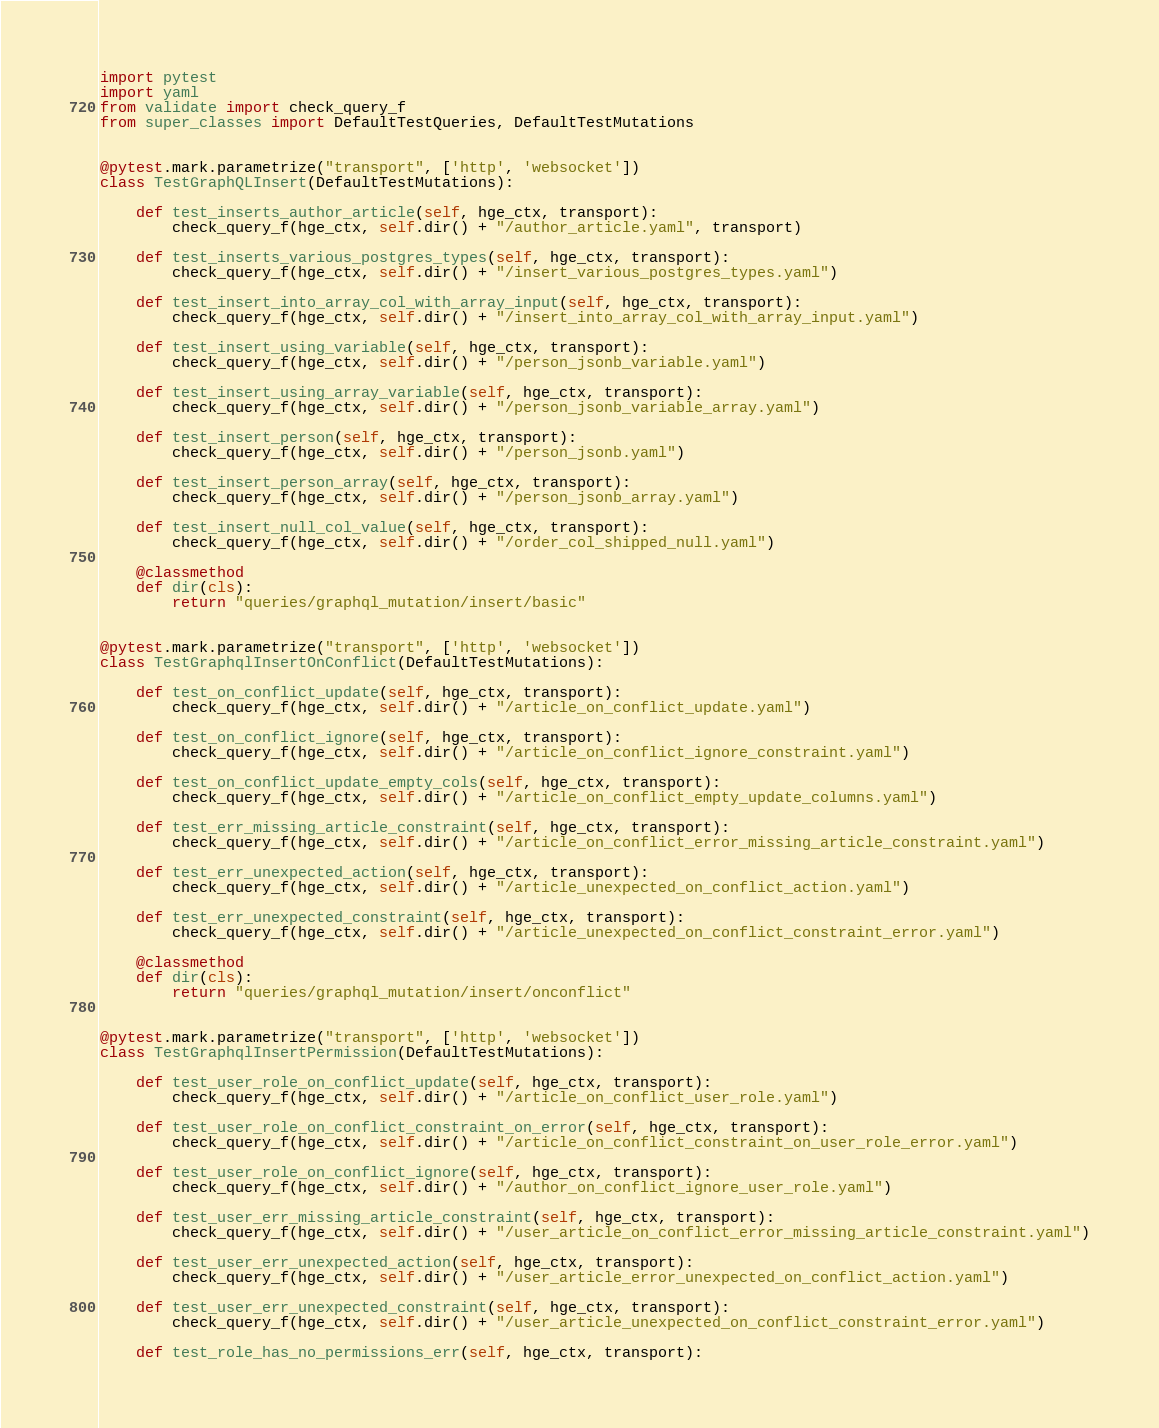<code> <loc_0><loc_0><loc_500><loc_500><_Python_>import pytest
import yaml
from validate import check_query_f
from super_classes import DefaultTestQueries, DefaultTestMutations


@pytest.mark.parametrize("transport", ['http', 'websocket'])
class TestGraphQLInsert(DefaultTestMutations):

    def test_inserts_author_article(self, hge_ctx, transport):
        check_query_f(hge_ctx, self.dir() + "/author_article.yaml", transport)

    def test_inserts_various_postgres_types(self, hge_ctx, transport):
        check_query_f(hge_ctx, self.dir() + "/insert_various_postgres_types.yaml")

    def test_insert_into_array_col_with_array_input(self, hge_ctx, transport):
        check_query_f(hge_ctx, self.dir() + "/insert_into_array_col_with_array_input.yaml")

    def test_insert_using_variable(self, hge_ctx, transport):
        check_query_f(hge_ctx, self.dir() + "/person_jsonb_variable.yaml")

    def test_insert_using_array_variable(self, hge_ctx, transport):
        check_query_f(hge_ctx, self.dir() + "/person_jsonb_variable_array.yaml")

    def test_insert_person(self, hge_ctx, transport):
        check_query_f(hge_ctx, self.dir() + "/person_jsonb.yaml")

    def test_insert_person_array(self, hge_ctx, transport):
        check_query_f(hge_ctx, self.dir() + "/person_jsonb_array.yaml")

    def test_insert_null_col_value(self, hge_ctx, transport):
        check_query_f(hge_ctx, self.dir() + "/order_col_shipped_null.yaml")

    @classmethod
    def dir(cls):
        return "queries/graphql_mutation/insert/basic"


@pytest.mark.parametrize("transport", ['http', 'websocket'])
class TestGraphqlInsertOnConflict(DefaultTestMutations):

    def test_on_conflict_update(self, hge_ctx, transport):
        check_query_f(hge_ctx, self.dir() + "/article_on_conflict_update.yaml")

    def test_on_conflict_ignore(self, hge_ctx, transport):
        check_query_f(hge_ctx, self.dir() + "/article_on_conflict_ignore_constraint.yaml")

    def test_on_conflict_update_empty_cols(self, hge_ctx, transport):
        check_query_f(hge_ctx, self.dir() + "/article_on_conflict_empty_update_columns.yaml")

    def test_err_missing_article_constraint(self, hge_ctx, transport):
        check_query_f(hge_ctx, self.dir() + "/article_on_conflict_error_missing_article_constraint.yaml")

    def test_err_unexpected_action(self, hge_ctx, transport):
        check_query_f(hge_ctx, self.dir() + "/article_unexpected_on_conflict_action.yaml")

    def test_err_unexpected_constraint(self, hge_ctx, transport):
        check_query_f(hge_ctx, self.dir() + "/article_unexpected_on_conflict_constraint_error.yaml")

    @classmethod
    def dir(cls):
        return "queries/graphql_mutation/insert/onconflict"


@pytest.mark.parametrize("transport", ['http', 'websocket'])
class TestGraphqlInsertPermission(DefaultTestMutations):

    def test_user_role_on_conflict_update(self, hge_ctx, transport):
        check_query_f(hge_ctx, self.dir() + "/article_on_conflict_user_role.yaml")

    def test_user_role_on_conflict_constraint_on_error(self, hge_ctx, transport):
        check_query_f(hge_ctx, self.dir() + "/article_on_conflict_constraint_on_user_role_error.yaml")

    def test_user_role_on_conflict_ignore(self, hge_ctx, transport):
        check_query_f(hge_ctx, self.dir() + "/author_on_conflict_ignore_user_role.yaml")

    def test_user_err_missing_article_constraint(self, hge_ctx, transport):
        check_query_f(hge_ctx, self.dir() + "/user_article_on_conflict_error_missing_article_constraint.yaml")

    def test_user_err_unexpected_action(self, hge_ctx, transport):
        check_query_f(hge_ctx, self.dir() + "/user_article_error_unexpected_on_conflict_action.yaml")

    def test_user_err_unexpected_constraint(self, hge_ctx, transport):
        check_query_f(hge_ctx, self.dir() + "/user_article_unexpected_on_conflict_constraint_error.yaml")

    def test_role_has_no_permissions_err(self, hge_ctx, transport):</code> 